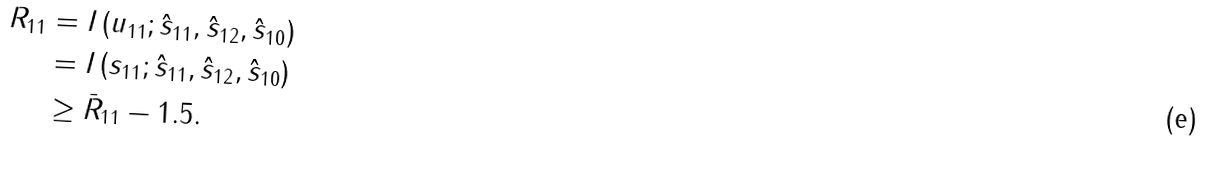<formula> <loc_0><loc_0><loc_500><loc_500>R _ { 1 1 } & = I \left ( u _ { 1 1 } ; \hat { s } _ { 1 1 } , \hat { s } _ { 1 2 } , \hat { s } _ { 1 0 } \right ) \\ & = I \left ( s _ { 1 1 } ; \hat { s } _ { 1 1 } , \hat { s } _ { 1 2 } , \hat { s } _ { 1 0 } \right ) \\ & \geq \bar { R } _ { 1 1 } - 1 . 5 .</formula> 